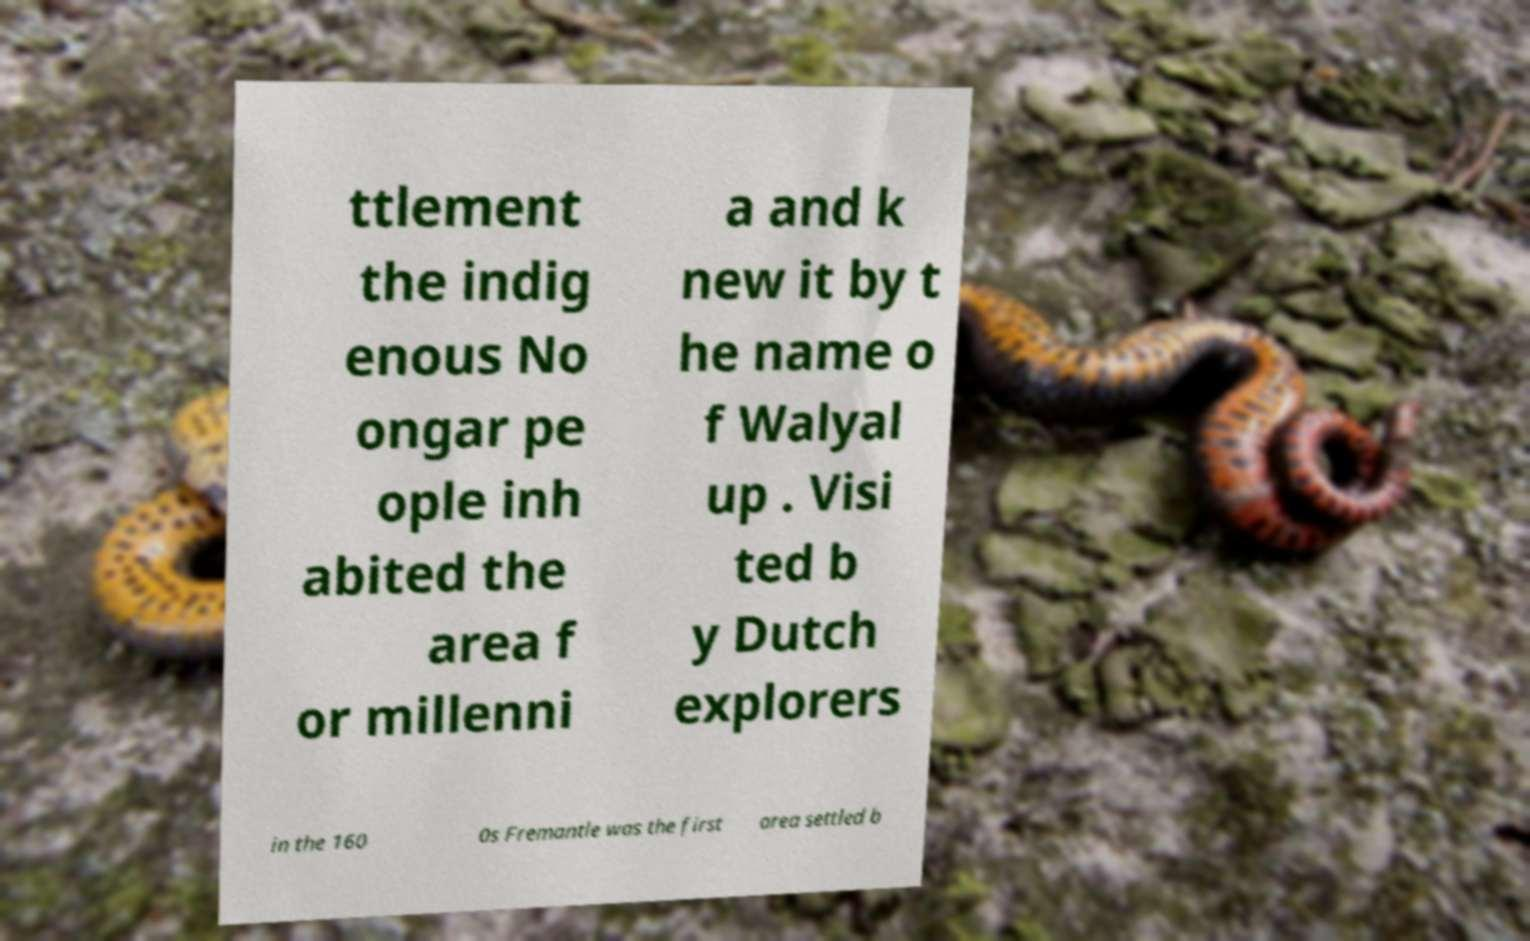Please identify and transcribe the text found in this image. ttlement the indig enous No ongar pe ople inh abited the area f or millenni a and k new it by t he name o f Walyal up . Visi ted b y Dutch explorers in the 160 0s Fremantle was the first area settled b 